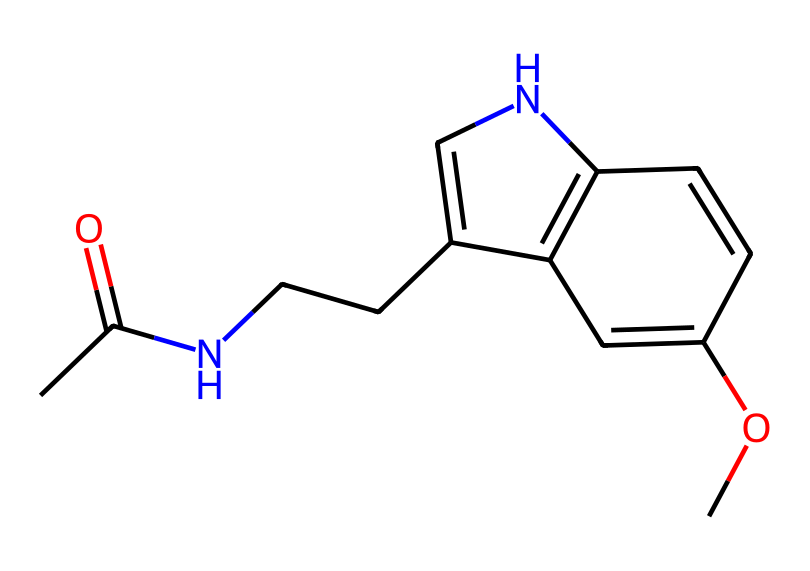What is the molecular formula of melatonin? By analyzing the provided SMILES representation, we can simplify it to identify the constituent atoms. Count the number of carbon (C), hydrogen (H), nitrogen (N), and oxygen (O) atoms present in the structure. The total counts sum up to C13H16N2O2.
Answer: C13H16N2O2 How many rings are in the structure of melatonin? Upon examining the structure derived from the SMILES notation, we can observe that there is one cyclic component within the larger structure. The presence of 'C1' indicates the start and closure of a cyclic arrangement, confirming there is one ring.
Answer: 1 What type of functional groups are present in melatonin? By analyzing the SMILES representation, we can identify key functional groups such as the amide group (indicated by the 'N' bonded to a carbonyl group) and the methoxy group (the 'O' connected to a carbon group). These functional groups contribute to the properties and biological activity of melatonin.
Answer: amide, methoxy Does melatonin contain any heteroatoms? In this context, heteroatoms refer to atoms in the molecular structure that are not carbon or hydrogen. From the SMILES representation, we see both nitrogen and oxygen atoms present within the compound, qualifying them as heteroatoms.
Answer: yes What is the significance of nitrogen in melatonin's structure? Nitrogen plays a critical role in melatonin's function as a hormone. The nitrogen atom is part of the indole structure, which is responsible for melatonin's biological activity and its role in regulating sleep patterns. This relationship highlights the importance of nitrogen in hormone signaling.
Answer: hormone signaling What is the primary role of melatonin in the body? Melatonin primarily functions as a regulator of circadian rhythms, which are essential for sleep-wake cycles. It helps in signaling the body when to prepare for sleep, thus influencing sleep patterns and overall alertness.
Answer: circadian rhythms How does melatonin’s molecular structure relate to its biological activity? The structure of melatonin, including its functional groups and the presence of nitrogen, supports its role in binding to specific receptors in the brain which modulate sleep. The planar nature and the indole ring structure enhance its ability to cross the blood-brain barrier, thus influencing its effectiveness as a hormone.
Answer: receptor binding 